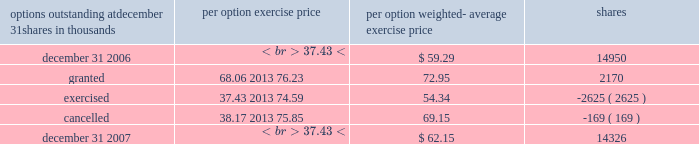Portion of their plan account invested in shares of pnc common stock into other investments available within the plan .
Prior to this amendment , only participants age 50 or older were permitted to exercise this diversification option .
Employee benefits expense related to this plan was $ 52 million in 2007 , $ 52 million in 2006 and $ 47 million in 2005 .
We measured employee benefits expense as the fair value of the shares and cash contributed to the plan by pnc .
Hilliard lyons sponsors a contributory , qualified defined contribution plan that covers substantially all of its employees who are not covered by the plan described above .
Contributions to this plan are made in cash and include a base contribution for those participants employed at december 31 , a matching of employee contributions , and a discretionary profit sharing contribution as determined by hilliard lyons 2019 executive compensation committee .
Employee benefits expense for this plan was $ 6 million in 2007 , $ 5 million in 2006 and $ 6 million in 2005 .
See note 2 acquisitions and divestitures regarding our pending sale of hilliard lyons .
We have a separate qualified defined contribution plan that covers substantially all us-based pfpc employees not covered by our plan .
The plan is a 401 ( k ) plan and includes an esop feature .
Under this plan , employee contributions of up to 6% ( 6 % ) of eligible compensation as defined by the plan may be matched annually based on pfpc performance levels .
Participants must be employed as of december 31 of each year to receive this annual contribution .
The performance- based employer matching contribution will be made primarily in shares of pnc common stock held in treasury , except in the case of those participants who have exercised their diversification election rights to have their matching portion in other investments available within the plan .
Mandatory employer contributions to this plan are made in cash and include employer basic and transitional contributions .
Employee-directed contributions are invested in a number of investment options available under the plan , including a pnc common stock fund and several blackrock mutual funds , at the direction of the employee .
Effective november 22 , 2005 , we amended the plan to provide all participants the ability to diversify the matching portion of their plan account invested in shares of pnc common stock into other investments available within the plan .
Prior to this amendment , only participants age 50 or older were permitted to exercise this diversification option .
Employee benefits expense for this plan was $ 10 million in 2007 , $ 9 million in 2006 and $ 12 million in 2005 .
We measured employee benefits expense as the fair value of the shares and cash contributed to the plan .
We also maintain a nonqualified supplemental savings plan for certain employees .
Note 18 stock-based compensation we have long-term incentive award plans ( 201cincentive plans 201d ) that provide for the granting of incentive stock options , nonqualified stock options , stock appreciation rights , incentive shares/performance units , restricted stock , restricted share units , other share-based awards and dollar-denominated awards to executives and , other than incentive stock options , to non-employee directors .
Certain incentive plan awards may be paid in stock , cash or a combination of stock and cash .
We grant a substantial portion of our stock-based compensation awards during the first quarter of the year .
As of december 31 , 2007 , no incentive stock options or stock appreciation rights were outstanding .
Nonqualified stock options options are granted at exercise prices not less than the market value of common stock on the grant date .
Generally , options granted since 1999 become exercisable in installments after the grant date .
Options granted prior to 1999 are mainly exercisable 12 months after the grant date .
No option may be exercisable after 10 years from its grant date .
Payment of the option exercise price may be in cash or shares of common stock at market value on the exercise date .
The exercise price may be paid in previously owned shares .
Generally , options granted under the incentive plans vest ratably over a three-year period as long as the grantee remains an employee or , in certain cases , retires from pnc .
For all options granted prior to the adoption of sfas 123r , we recognized compensation expense over the three-year vesting period .
If an employee retired prior to the end of the three- year vesting period , we accelerated the expensing of all unrecognized compensation costs at the retirement date .
As required under sfas 123r , we recognize compensation expense for options granted to retirement-eligible employees after january 1 , 2006 in the period granted , in accordance with the service period provisions of the options .
A summary of stock option activity follows: .

What was the net change in weighted average exercise price for 2007? 
Computations: (62.15 - 59.29)
Answer: 2.86. 